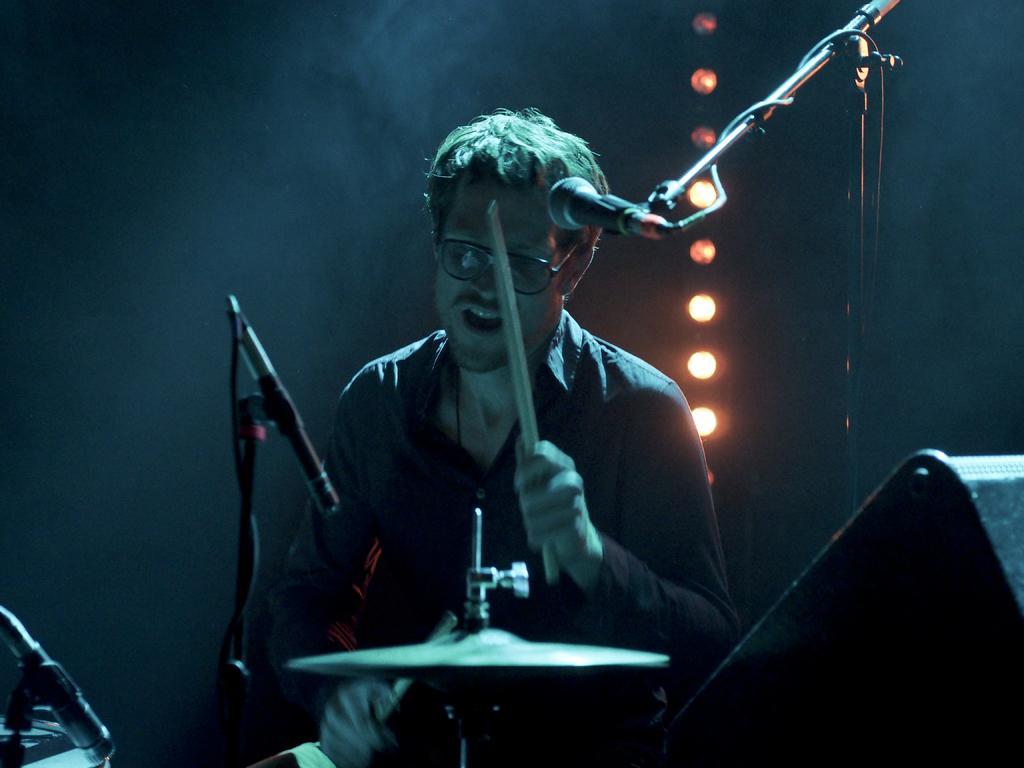What is the person in the image doing? The person is playing drums and singing on a mic. Can you describe the person's activity in more detail? The person is playing drums with their hands and singing into a microphone. What can be seen on the wall in the image? There are lights on the wall in the image. What type of sense is the person using to play the drums in the image? The person is using their sense of touch to play the drums, as they are using their hands to hit the drum surface. 